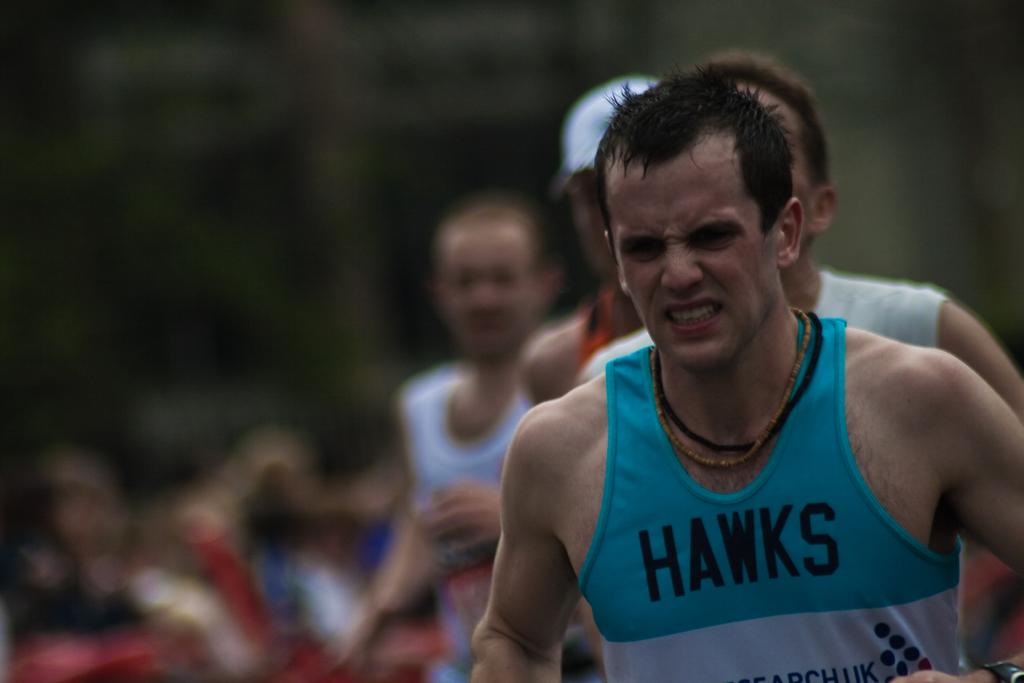How many people are standing on the ground in the image? There are four persons standing on the ground in the image. Can you describe the clothing of one of the persons? One person is wearing a blue t-shirt. What can be seen in the background of the image? There is a group of people in the background of the image. What type of music can be heard coming from the person wearing the blue t-shirt in the image? There is no indication in the image that the person wearing of a blue t-shirt is associated with any music, so it cannot be determined from the picture. 